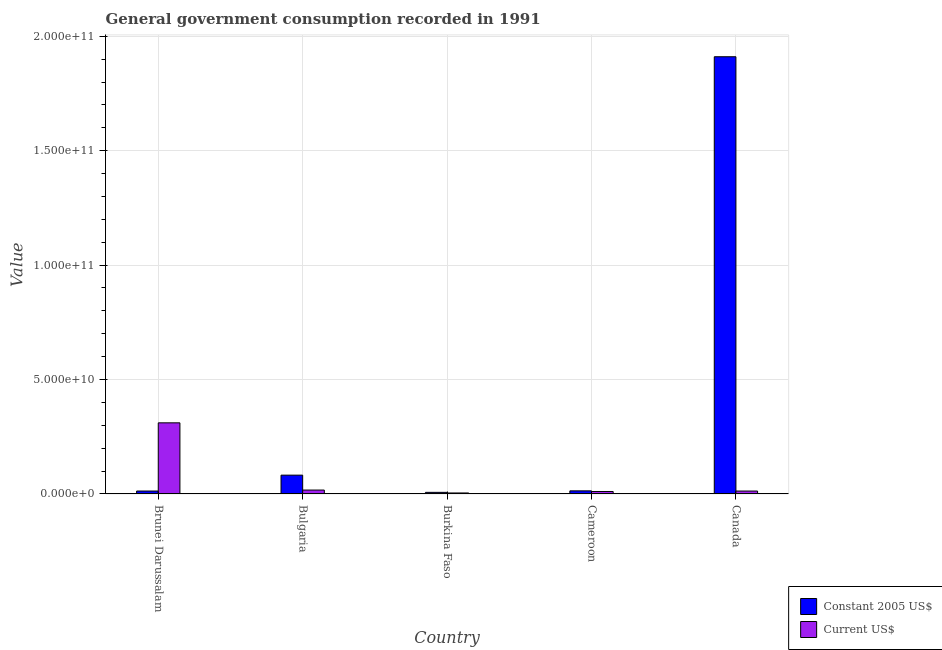How many bars are there on the 3rd tick from the right?
Give a very brief answer. 2. What is the label of the 1st group of bars from the left?
Your response must be concise. Brunei Darussalam. In how many cases, is the number of bars for a given country not equal to the number of legend labels?
Your answer should be compact. 0. What is the value consumed in current us$ in Bulgaria?
Provide a succinct answer. 1.71e+09. Across all countries, what is the maximum value consumed in current us$?
Offer a very short reply. 3.11e+1. Across all countries, what is the minimum value consumed in constant 2005 us$?
Your answer should be compact. 7.08e+08. In which country was the value consumed in constant 2005 us$ maximum?
Offer a very short reply. Canada. In which country was the value consumed in current us$ minimum?
Your answer should be compact. Burkina Faso. What is the total value consumed in current us$ in the graph?
Provide a succinct answer. 3.56e+1. What is the difference between the value consumed in current us$ in Brunei Darussalam and that in Cameroon?
Your response must be concise. 3.00e+1. What is the difference between the value consumed in constant 2005 us$ in Burkina Faso and the value consumed in current us$ in Cameroon?
Give a very brief answer. -3.72e+08. What is the average value consumed in constant 2005 us$ per country?
Your response must be concise. 4.05e+1. What is the difference between the value consumed in constant 2005 us$ and value consumed in current us$ in Brunei Darussalam?
Your answer should be very brief. -2.98e+1. What is the ratio of the value consumed in constant 2005 us$ in Brunei Darussalam to that in Bulgaria?
Your answer should be compact. 0.16. Is the value consumed in constant 2005 us$ in Cameroon less than that in Canada?
Make the answer very short. Yes. Is the difference between the value consumed in constant 2005 us$ in Brunei Darussalam and Canada greater than the difference between the value consumed in current us$ in Brunei Darussalam and Canada?
Ensure brevity in your answer.  No. What is the difference between the highest and the second highest value consumed in current us$?
Provide a succinct answer. 2.94e+1. What is the difference between the highest and the lowest value consumed in current us$?
Ensure brevity in your answer.  3.06e+1. What does the 1st bar from the left in Bulgaria represents?
Offer a very short reply. Constant 2005 US$. What does the 2nd bar from the right in Cameroon represents?
Offer a very short reply. Constant 2005 US$. How many bars are there?
Give a very brief answer. 10. Are the values on the major ticks of Y-axis written in scientific E-notation?
Your answer should be compact. Yes. Does the graph contain any zero values?
Provide a succinct answer. No. Does the graph contain grids?
Ensure brevity in your answer.  Yes. Where does the legend appear in the graph?
Your answer should be very brief. Bottom right. What is the title of the graph?
Keep it short and to the point. General government consumption recorded in 1991. What is the label or title of the Y-axis?
Keep it short and to the point. Value. What is the Value in Constant 2005 US$ in Brunei Darussalam?
Offer a terse response. 1.29e+09. What is the Value in Current US$ in Brunei Darussalam?
Your answer should be compact. 3.11e+1. What is the Value of Constant 2005 US$ in Bulgaria?
Your answer should be compact. 8.23e+09. What is the Value in Current US$ in Bulgaria?
Ensure brevity in your answer.  1.71e+09. What is the Value of Constant 2005 US$ in Burkina Faso?
Provide a succinct answer. 7.08e+08. What is the Value of Current US$ in Burkina Faso?
Give a very brief answer. 4.41e+08. What is the Value in Constant 2005 US$ in Cameroon?
Make the answer very short. 1.36e+09. What is the Value in Current US$ in Cameroon?
Your answer should be compact. 1.08e+09. What is the Value in Constant 2005 US$ in Canada?
Your answer should be compact. 1.91e+11. What is the Value of Current US$ in Canada?
Make the answer very short. 1.28e+09. Across all countries, what is the maximum Value of Constant 2005 US$?
Provide a short and direct response. 1.91e+11. Across all countries, what is the maximum Value in Current US$?
Offer a terse response. 3.11e+1. Across all countries, what is the minimum Value in Constant 2005 US$?
Make the answer very short. 7.08e+08. Across all countries, what is the minimum Value in Current US$?
Make the answer very short. 4.41e+08. What is the total Value of Constant 2005 US$ in the graph?
Make the answer very short. 2.03e+11. What is the total Value of Current US$ in the graph?
Provide a short and direct response. 3.56e+1. What is the difference between the Value in Constant 2005 US$ in Brunei Darussalam and that in Bulgaria?
Offer a terse response. -6.94e+09. What is the difference between the Value of Current US$ in Brunei Darussalam and that in Bulgaria?
Your answer should be very brief. 2.94e+1. What is the difference between the Value of Constant 2005 US$ in Brunei Darussalam and that in Burkina Faso?
Keep it short and to the point. 5.80e+08. What is the difference between the Value in Current US$ in Brunei Darussalam and that in Burkina Faso?
Give a very brief answer. 3.06e+1. What is the difference between the Value in Constant 2005 US$ in Brunei Darussalam and that in Cameroon?
Offer a very short reply. -7.65e+07. What is the difference between the Value in Current US$ in Brunei Darussalam and that in Cameroon?
Provide a succinct answer. 3.00e+1. What is the difference between the Value in Constant 2005 US$ in Brunei Darussalam and that in Canada?
Your answer should be very brief. -1.90e+11. What is the difference between the Value in Current US$ in Brunei Darussalam and that in Canada?
Your response must be concise. 2.98e+1. What is the difference between the Value of Constant 2005 US$ in Bulgaria and that in Burkina Faso?
Make the answer very short. 7.52e+09. What is the difference between the Value of Current US$ in Bulgaria and that in Burkina Faso?
Give a very brief answer. 1.27e+09. What is the difference between the Value in Constant 2005 US$ in Bulgaria and that in Cameroon?
Offer a very short reply. 6.86e+09. What is the difference between the Value in Current US$ in Bulgaria and that in Cameroon?
Ensure brevity in your answer.  6.28e+08. What is the difference between the Value of Constant 2005 US$ in Bulgaria and that in Canada?
Keep it short and to the point. -1.83e+11. What is the difference between the Value of Current US$ in Bulgaria and that in Canada?
Keep it short and to the point. 4.27e+08. What is the difference between the Value of Constant 2005 US$ in Burkina Faso and that in Cameroon?
Provide a succinct answer. -6.57e+08. What is the difference between the Value of Current US$ in Burkina Faso and that in Cameroon?
Keep it short and to the point. -6.39e+08. What is the difference between the Value in Constant 2005 US$ in Burkina Faso and that in Canada?
Give a very brief answer. -1.90e+11. What is the difference between the Value in Current US$ in Burkina Faso and that in Canada?
Offer a terse response. -8.40e+08. What is the difference between the Value of Constant 2005 US$ in Cameroon and that in Canada?
Make the answer very short. -1.90e+11. What is the difference between the Value of Current US$ in Cameroon and that in Canada?
Give a very brief answer. -2.01e+08. What is the difference between the Value of Constant 2005 US$ in Brunei Darussalam and the Value of Current US$ in Bulgaria?
Provide a succinct answer. -4.19e+08. What is the difference between the Value of Constant 2005 US$ in Brunei Darussalam and the Value of Current US$ in Burkina Faso?
Your answer should be very brief. 8.48e+08. What is the difference between the Value of Constant 2005 US$ in Brunei Darussalam and the Value of Current US$ in Cameroon?
Keep it short and to the point. 2.09e+08. What is the difference between the Value of Constant 2005 US$ in Brunei Darussalam and the Value of Current US$ in Canada?
Keep it short and to the point. 7.88e+06. What is the difference between the Value of Constant 2005 US$ in Bulgaria and the Value of Current US$ in Burkina Faso?
Ensure brevity in your answer.  7.78e+09. What is the difference between the Value in Constant 2005 US$ in Bulgaria and the Value in Current US$ in Cameroon?
Offer a terse response. 7.15e+09. What is the difference between the Value in Constant 2005 US$ in Bulgaria and the Value in Current US$ in Canada?
Provide a short and direct response. 6.94e+09. What is the difference between the Value in Constant 2005 US$ in Burkina Faso and the Value in Current US$ in Cameroon?
Your response must be concise. -3.72e+08. What is the difference between the Value of Constant 2005 US$ in Burkina Faso and the Value of Current US$ in Canada?
Offer a terse response. -5.73e+08. What is the difference between the Value of Constant 2005 US$ in Cameroon and the Value of Current US$ in Canada?
Ensure brevity in your answer.  8.43e+07. What is the average Value of Constant 2005 US$ per country?
Give a very brief answer. 4.05e+1. What is the average Value of Current US$ per country?
Ensure brevity in your answer.  7.12e+09. What is the difference between the Value in Constant 2005 US$ and Value in Current US$ in Brunei Darussalam?
Give a very brief answer. -2.98e+1. What is the difference between the Value of Constant 2005 US$ and Value of Current US$ in Bulgaria?
Your answer should be very brief. 6.52e+09. What is the difference between the Value in Constant 2005 US$ and Value in Current US$ in Burkina Faso?
Ensure brevity in your answer.  2.67e+08. What is the difference between the Value in Constant 2005 US$ and Value in Current US$ in Cameroon?
Your answer should be compact. 2.85e+08. What is the difference between the Value of Constant 2005 US$ and Value of Current US$ in Canada?
Make the answer very short. 1.90e+11. What is the ratio of the Value of Constant 2005 US$ in Brunei Darussalam to that in Bulgaria?
Make the answer very short. 0.16. What is the ratio of the Value in Current US$ in Brunei Darussalam to that in Bulgaria?
Your response must be concise. 18.2. What is the ratio of the Value of Constant 2005 US$ in Brunei Darussalam to that in Burkina Faso?
Make the answer very short. 1.82. What is the ratio of the Value in Current US$ in Brunei Darussalam to that in Burkina Faso?
Make the answer very short. 70.55. What is the ratio of the Value of Constant 2005 US$ in Brunei Darussalam to that in Cameroon?
Your answer should be compact. 0.94. What is the ratio of the Value of Current US$ in Brunei Darussalam to that in Cameroon?
Keep it short and to the point. 28.79. What is the ratio of the Value in Constant 2005 US$ in Brunei Darussalam to that in Canada?
Offer a terse response. 0.01. What is the ratio of the Value of Current US$ in Brunei Darussalam to that in Canada?
Offer a terse response. 24.27. What is the ratio of the Value in Constant 2005 US$ in Bulgaria to that in Burkina Faso?
Your answer should be very brief. 11.62. What is the ratio of the Value in Current US$ in Bulgaria to that in Burkina Faso?
Your response must be concise. 3.88. What is the ratio of the Value of Constant 2005 US$ in Bulgaria to that in Cameroon?
Ensure brevity in your answer.  6.03. What is the ratio of the Value of Current US$ in Bulgaria to that in Cameroon?
Give a very brief answer. 1.58. What is the ratio of the Value in Constant 2005 US$ in Bulgaria to that in Canada?
Give a very brief answer. 0.04. What is the ratio of the Value of Current US$ in Bulgaria to that in Canada?
Give a very brief answer. 1.33. What is the ratio of the Value in Constant 2005 US$ in Burkina Faso to that in Cameroon?
Ensure brevity in your answer.  0.52. What is the ratio of the Value in Current US$ in Burkina Faso to that in Cameroon?
Keep it short and to the point. 0.41. What is the ratio of the Value of Constant 2005 US$ in Burkina Faso to that in Canada?
Ensure brevity in your answer.  0. What is the ratio of the Value in Current US$ in Burkina Faso to that in Canada?
Provide a short and direct response. 0.34. What is the ratio of the Value of Constant 2005 US$ in Cameroon to that in Canada?
Your answer should be compact. 0.01. What is the ratio of the Value in Current US$ in Cameroon to that in Canada?
Provide a succinct answer. 0.84. What is the difference between the highest and the second highest Value in Constant 2005 US$?
Keep it short and to the point. 1.83e+11. What is the difference between the highest and the second highest Value in Current US$?
Offer a terse response. 2.94e+1. What is the difference between the highest and the lowest Value of Constant 2005 US$?
Provide a short and direct response. 1.90e+11. What is the difference between the highest and the lowest Value of Current US$?
Provide a succinct answer. 3.06e+1. 